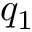Convert formula to latex. <formula><loc_0><loc_0><loc_500><loc_500>q _ { 1 }</formula> 